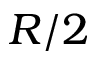Convert formula to latex. <formula><loc_0><loc_0><loc_500><loc_500>R / 2</formula> 